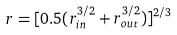<formula> <loc_0><loc_0><loc_500><loc_500>r = [ 0 . 5 ( r ^ { 3 / 2 } _ { i n } + r ^ { 3 / 2 } _ { o u t } ) ] ^ { 2 / 3 }</formula> 